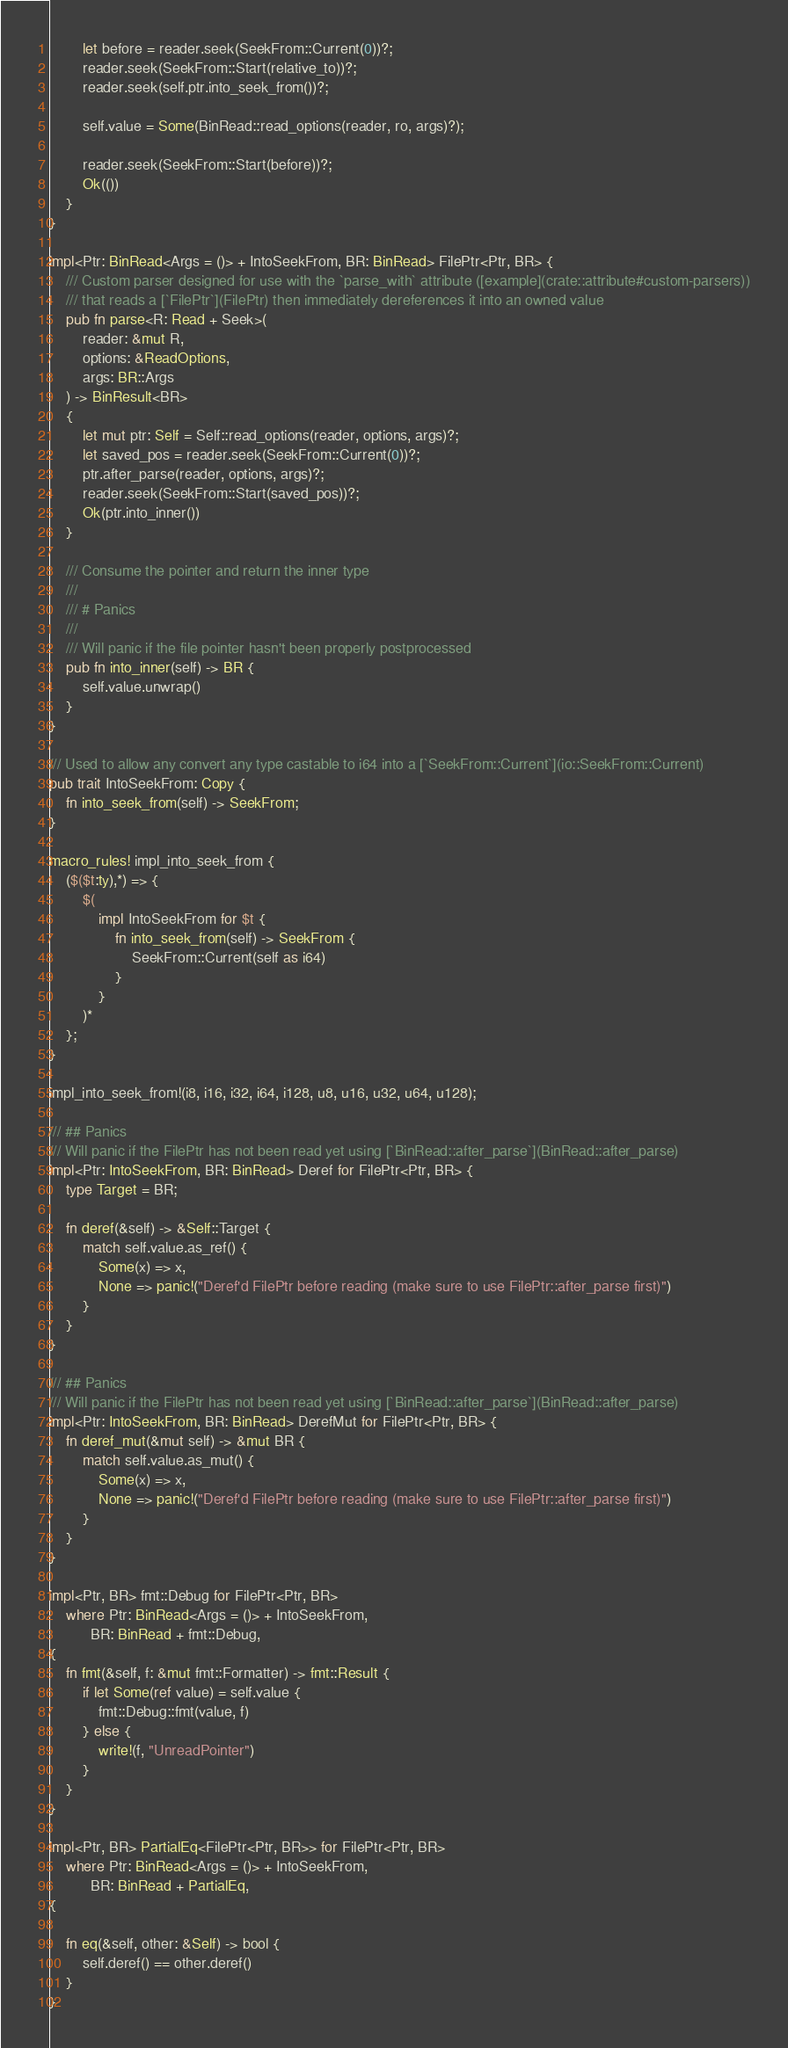<code> <loc_0><loc_0><loc_500><loc_500><_Rust_>        let before = reader.seek(SeekFrom::Current(0))?;
        reader.seek(SeekFrom::Start(relative_to))?;
        reader.seek(self.ptr.into_seek_from())?;

        self.value = Some(BinRead::read_options(reader, ro, args)?);

        reader.seek(SeekFrom::Start(before))?;
        Ok(())
    }
}

impl<Ptr: BinRead<Args = ()> + IntoSeekFrom, BR: BinRead> FilePtr<Ptr, BR> {
    /// Custom parser designed for use with the `parse_with` attribute ([example](crate::attribute#custom-parsers))
    /// that reads a [`FilePtr`](FilePtr) then immediately dereferences it into an owned value
    pub fn parse<R: Read + Seek>(
        reader: &mut R,
        options: &ReadOptions,
        args: BR::Args
    ) -> BinResult<BR>
    {
        let mut ptr: Self = Self::read_options(reader, options, args)?;
        let saved_pos = reader.seek(SeekFrom::Current(0))?;
        ptr.after_parse(reader, options, args)?;
        reader.seek(SeekFrom::Start(saved_pos))?;
        Ok(ptr.into_inner())
    }

    /// Consume the pointer and return the inner type
    /// 
    /// # Panics
    /// 
    /// Will panic if the file pointer hasn't been properly postprocessed
    pub fn into_inner(self) -> BR {
        self.value.unwrap()
    }
}

/// Used to allow any convert any type castable to i64 into a [`SeekFrom::Current`](io::SeekFrom::Current)
pub trait IntoSeekFrom: Copy {
    fn into_seek_from(self) -> SeekFrom;
}

macro_rules! impl_into_seek_from {
    ($($t:ty),*) => {
        $(
            impl IntoSeekFrom for $t {
                fn into_seek_from(self) -> SeekFrom {
                    SeekFrom::Current(self as i64)
                }
            }
        )*
    };
}

impl_into_seek_from!(i8, i16, i32, i64, i128, u8, u16, u32, u64, u128);

/// ## Panics
/// Will panic if the FilePtr has not been read yet using [`BinRead::after_parse`](BinRead::after_parse)
impl<Ptr: IntoSeekFrom, BR: BinRead> Deref for FilePtr<Ptr, BR> {
    type Target = BR;

    fn deref(&self) -> &Self::Target {
        match self.value.as_ref() {
            Some(x) => x,
            None => panic!("Deref'd FilePtr before reading (make sure to use FilePtr::after_parse first)")
        }
    }
}

/// ## Panics
/// Will panic if the FilePtr has not been read yet using [`BinRead::after_parse`](BinRead::after_parse)
impl<Ptr: IntoSeekFrom, BR: BinRead> DerefMut for FilePtr<Ptr, BR> {
    fn deref_mut(&mut self) -> &mut BR {
        match self.value.as_mut() {
            Some(x) => x,
            None => panic!("Deref'd FilePtr before reading (make sure to use FilePtr::after_parse first)")
        }
    }
}

impl<Ptr, BR> fmt::Debug for FilePtr<Ptr, BR>
    where Ptr: BinRead<Args = ()> + IntoSeekFrom,
          BR: BinRead + fmt::Debug,
{
    fn fmt(&self, f: &mut fmt::Formatter) -> fmt::Result {
        if let Some(ref value) = self.value {
            fmt::Debug::fmt(value, f)
        } else {
            write!(f, "UnreadPointer")
        }
    }
}

impl<Ptr, BR> PartialEq<FilePtr<Ptr, BR>> for FilePtr<Ptr, BR> 
    where Ptr: BinRead<Args = ()> + IntoSeekFrom,
          BR: BinRead + PartialEq,
{

    fn eq(&self, other: &Self) -> bool {
        self.deref() == other.deref()
    }
}</code> 